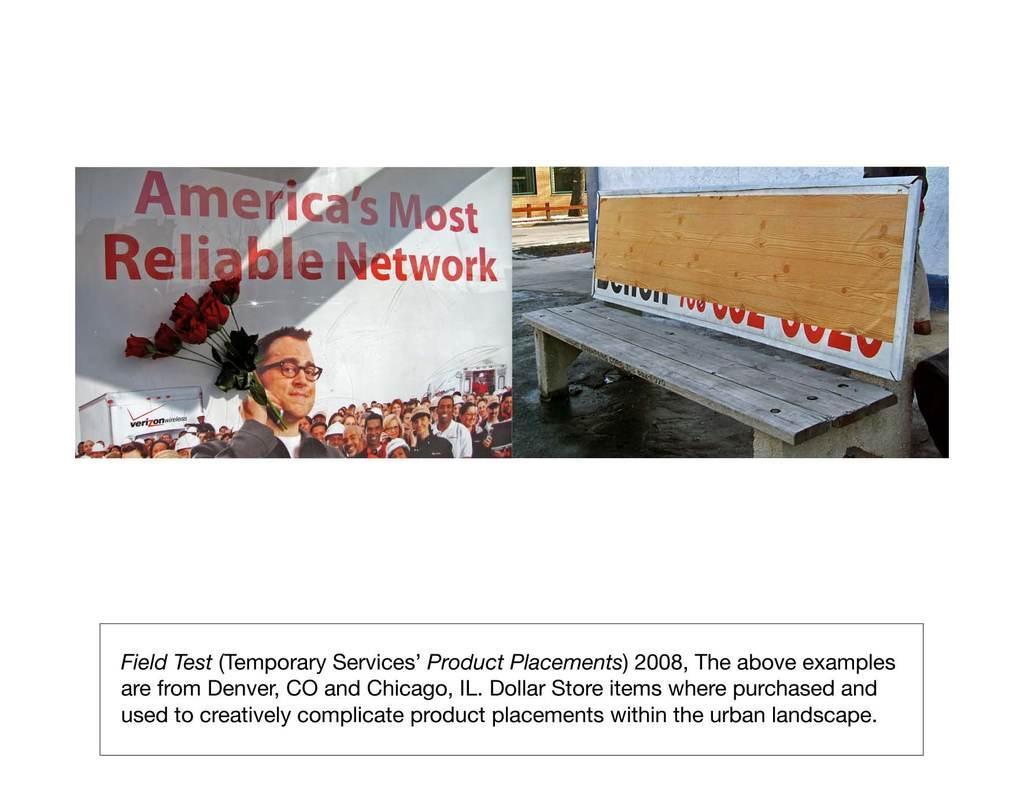How would you summarize this image in a sentence or two? In this image we can see two different images in a single picture where as on the left side we can see flowers on the banner and on the right side we can see a bench, person, walls and windows. At the bottom we can see sentence written on the image in a box. 